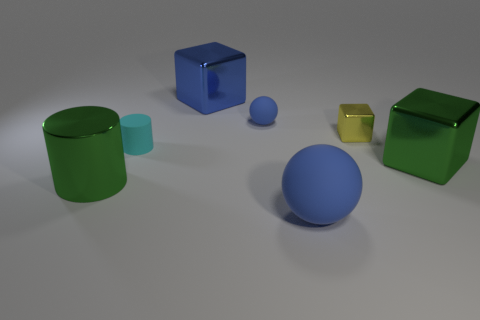Add 3 big blocks. How many objects exist? 10 Subtract all large metal cubes. How many cubes are left? 1 Subtract 1 cubes. How many cubes are left? 2 Subtract all yellow cubes. How many cubes are left? 2 Subtract all blocks. How many objects are left? 4 Add 5 metallic objects. How many metallic objects exist? 9 Subtract 0 yellow balls. How many objects are left? 7 Subtract all purple cylinders. Subtract all blue spheres. How many cylinders are left? 2 Subtract all gray blocks. How many green cylinders are left? 1 Subtract all big blue metallic blocks. Subtract all tiny blue spheres. How many objects are left? 5 